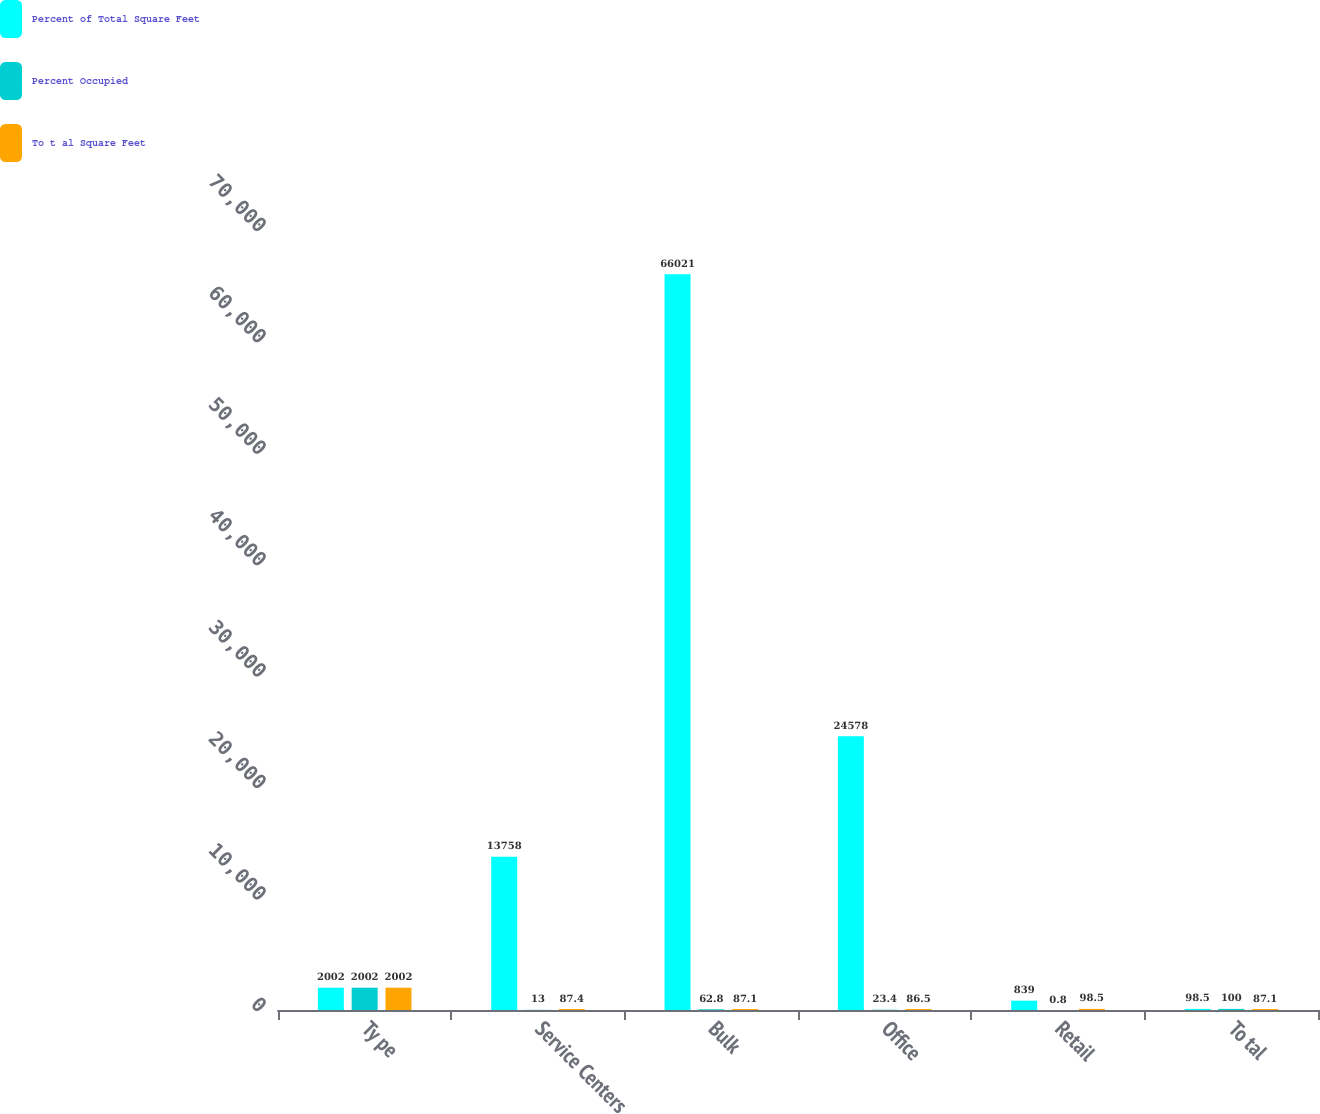Convert chart. <chart><loc_0><loc_0><loc_500><loc_500><stacked_bar_chart><ecel><fcel>Ty pe<fcel>Service Centers<fcel>Bulk<fcel>Office<fcel>Retail<fcel>To tal<nl><fcel>Percent of Total Square Feet<fcel>2002<fcel>13758<fcel>66021<fcel>24578<fcel>839<fcel>98.5<nl><fcel>Percent Occupied<fcel>2002<fcel>13<fcel>62.8<fcel>23.4<fcel>0.8<fcel>100<nl><fcel>To t al Square Feet<fcel>2002<fcel>87.4<fcel>87.1<fcel>86.5<fcel>98.5<fcel>87.1<nl></chart> 